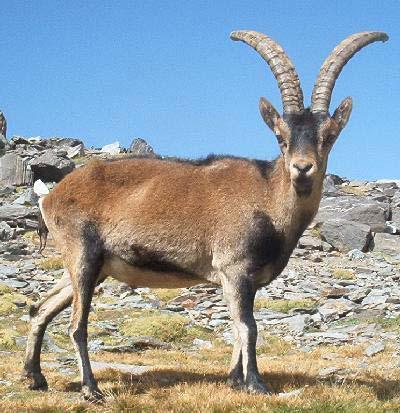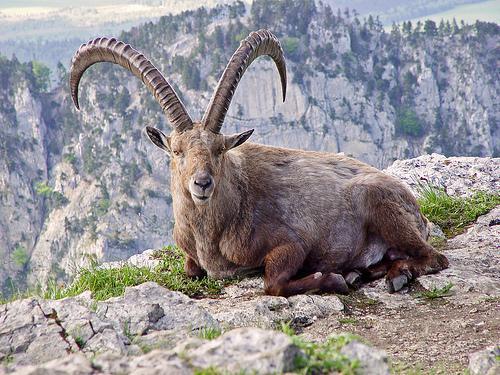The first image is the image on the left, the second image is the image on the right. Considering the images on both sides, is "Left image shows a horned animal standing on non-grassy surface with body and head in profile turned leftward." valid? Answer yes or no. No. 